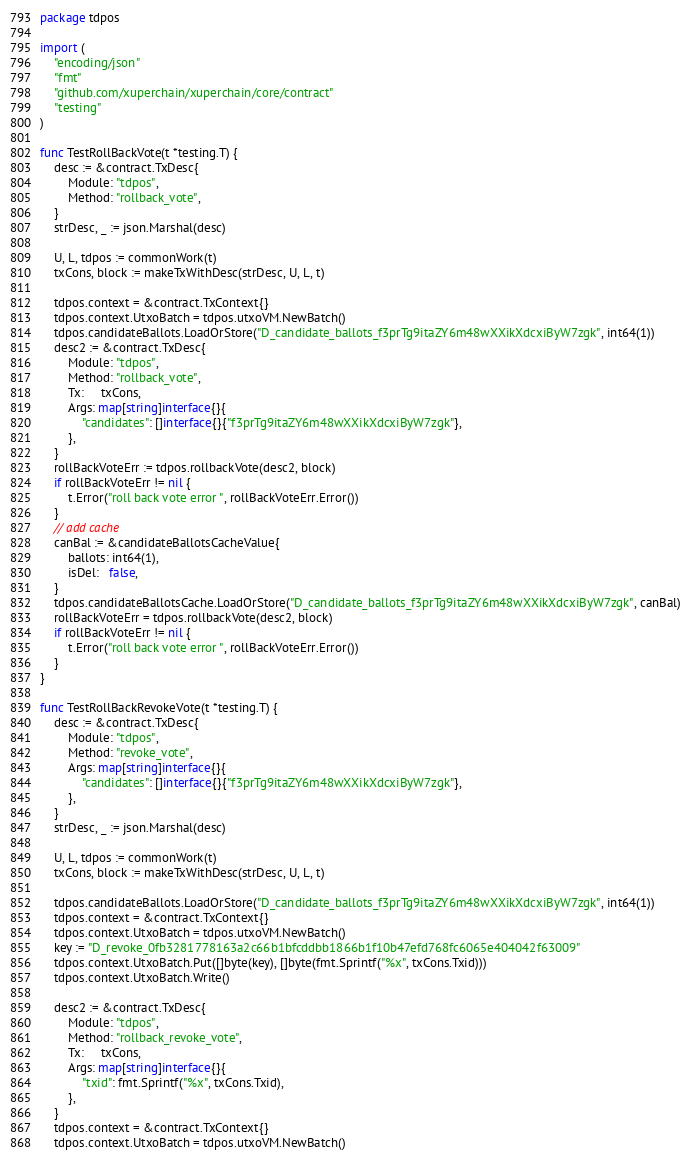<code> <loc_0><loc_0><loc_500><loc_500><_Go_>package tdpos

import (
	"encoding/json"
	"fmt"
	"github.com/xuperchain/xuperchain/core/contract"
	"testing"
)

func TestRollBackVote(t *testing.T) {
	desc := &contract.TxDesc{
		Module: "tdpos",
		Method: "rollback_vote",
	}
	strDesc, _ := json.Marshal(desc)

	U, L, tdpos := commonWork(t)
	txCons, block := makeTxWithDesc(strDesc, U, L, t)

	tdpos.context = &contract.TxContext{}
	tdpos.context.UtxoBatch = tdpos.utxoVM.NewBatch()
	tdpos.candidateBallots.LoadOrStore("D_candidate_ballots_f3prTg9itaZY6m48wXXikXdcxiByW7zgk", int64(1))
	desc2 := &contract.TxDesc{
		Module: "tdpos",
		Method: "rollback_vote",
		Tx:     txCons,
		Args: map[string]interface{}{
			"candidates": []interface{}{"f3prTg9itaZY6m48wXXikXdcxiByW7zgk"},
		},
	}
	rollBackVoteErr := tdpos.rollbackVote(desc2, block)
	if rollBackVoteErr != nil {
		t.Error("roll back vote error ", rollBackVoteErr.Error())
	}
	// add cache
	canBal := &candidateBallotsCacheValue{
		ballots: int64(1),
		isDel:   false,
	}
	tdpos.candidateBallotsCache.LoadOrStore("D_candidate_ballots_f3prTg9itaZY6m48wXXikXdcxiByW7zgk", canBal)
	rollBackVoteErr = tdpos.rollbackVote(desc2, block)
	if rollBackVoteErr != nil {
		t.Error("roll back vote error ", rollBackVoteErr.Error())
	}
}

func TestRollBackRevokeVote(t *testing.T) {
	desc := &contract.TxDesc{
		Module: "tdpos",
		Method: "revoke_vote",
		Args: map[string]interface{}{
			"candidates": []interface{}{"f3prTg9itaZY6m48wXXikXdcxiByW7zgk"},
		},
	}
	strDesc, _ := json.Marshal(desc)

	U, L, tdpos := commonWork(t)
	txCons, block := makeTxWithDesc(strDesc, U, L, t)

	tdpos.candidateBallots.LoadOrStore("D_candidate_ballots_f3prTg9itaZY6m48wXXikXdcxiByW7zgk", int64(1))
	tdpos.context = &contract.TxContext{}
	tdpos.context.UtxoBatch = tdpos.utxoVM.NewBatch()
	key := "D_revoke_0fb3281778163a2c66b1bfcddbb1866b1f10b47efd768fc6065e404042f63009"
	tdpos.context.UtxoBatch.Put([]byte(key), []byte(fmt.Sprintf("%x", txCons.Txid)))
	tdpos.context.UtxoBatch.Write()

	desc2 := &contract.TxDesc{
		Module: "tdpos",
		Method: "rollback_revoke_vote",
		Tx:     txCons,
		Args: map[string]interface{}{
			"txid": fmt.Sprintf("%x", txCons.Txid),
		},
	}
	tdpos.context = &contract.TxContext{}
	tdpos.context.UtxoBatch = tdpos.utxoVM.NewBatch()</code> 